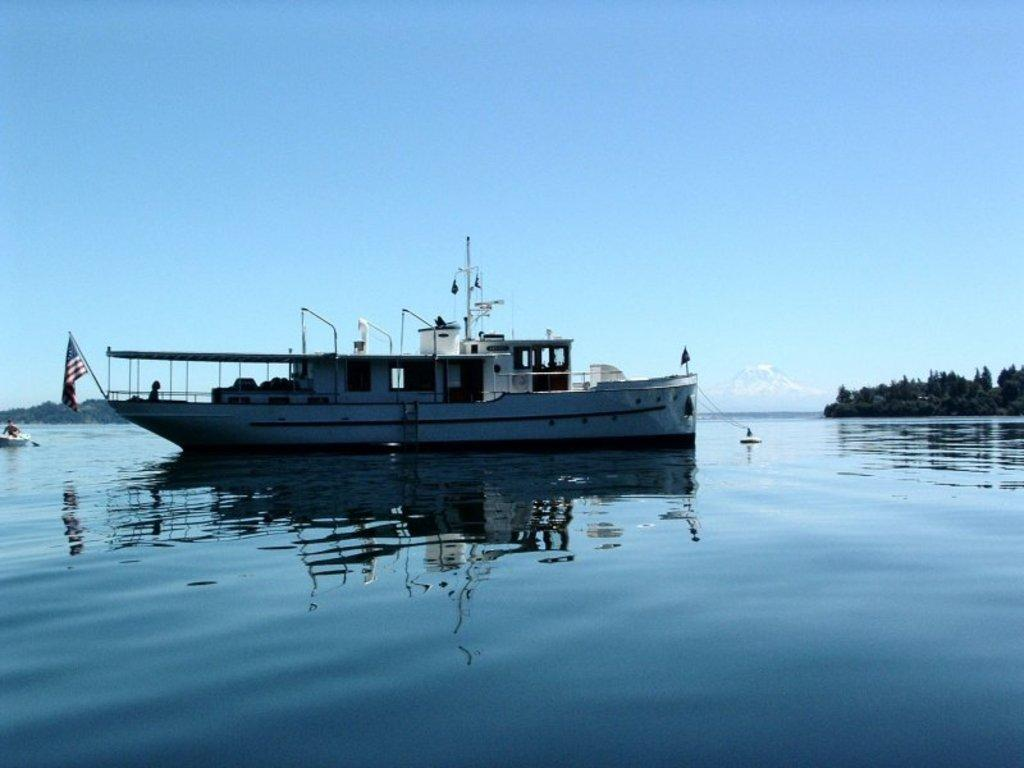What is the main subject of the image? The main subject of the image is a boat. What is the boat doing in the image? The boat is sailing on the water. What can be seen in the background of the image? There are trees in the background of the image. How does the boat use its brake while sailing in the image? Boats do not have brakes, as they are propelled by water and not by wheels. The boat in the image is sailing, not driving. 